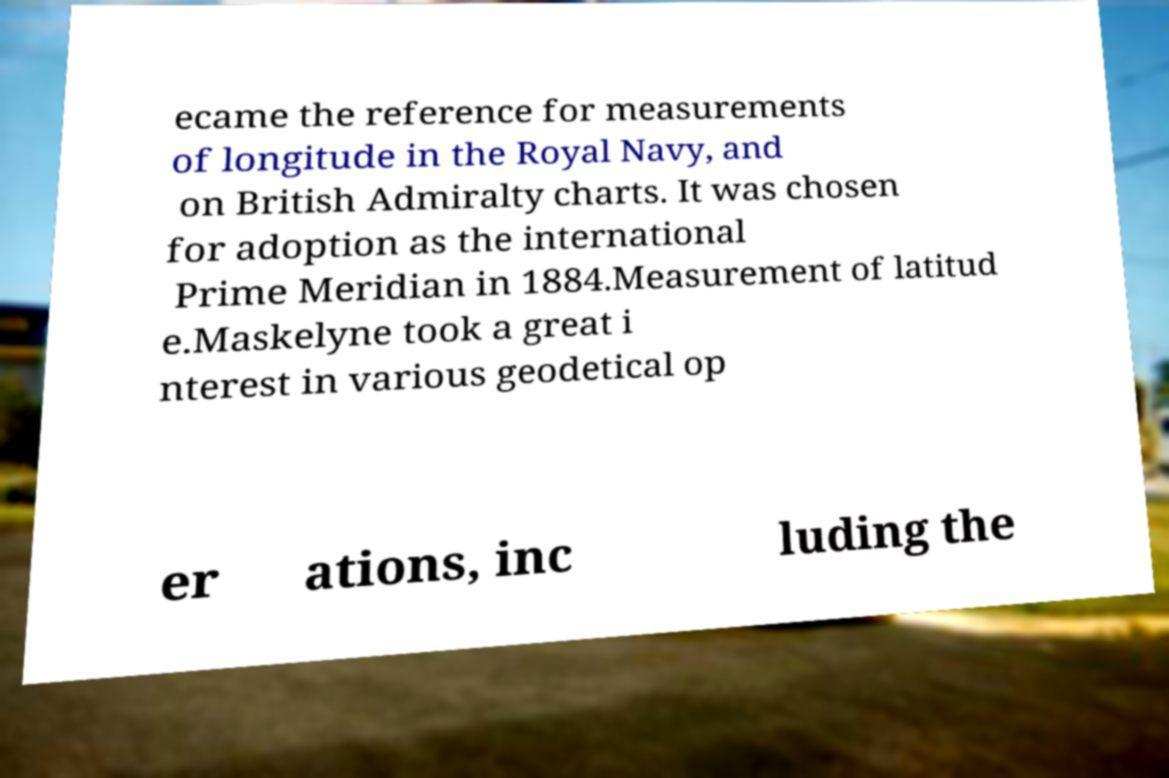There's text embedded in this image that I need extracted. Can you transcribe it verbatim? ecame the reference for measurements of longitude in the Royal Navy, and on British Admiralty charts. It was chosen for adoption as the international Prime Meridian in 1884.Measurement of latitud e.Maskelyne took a great i nterest in various geodetical op er ations, inc luding the 